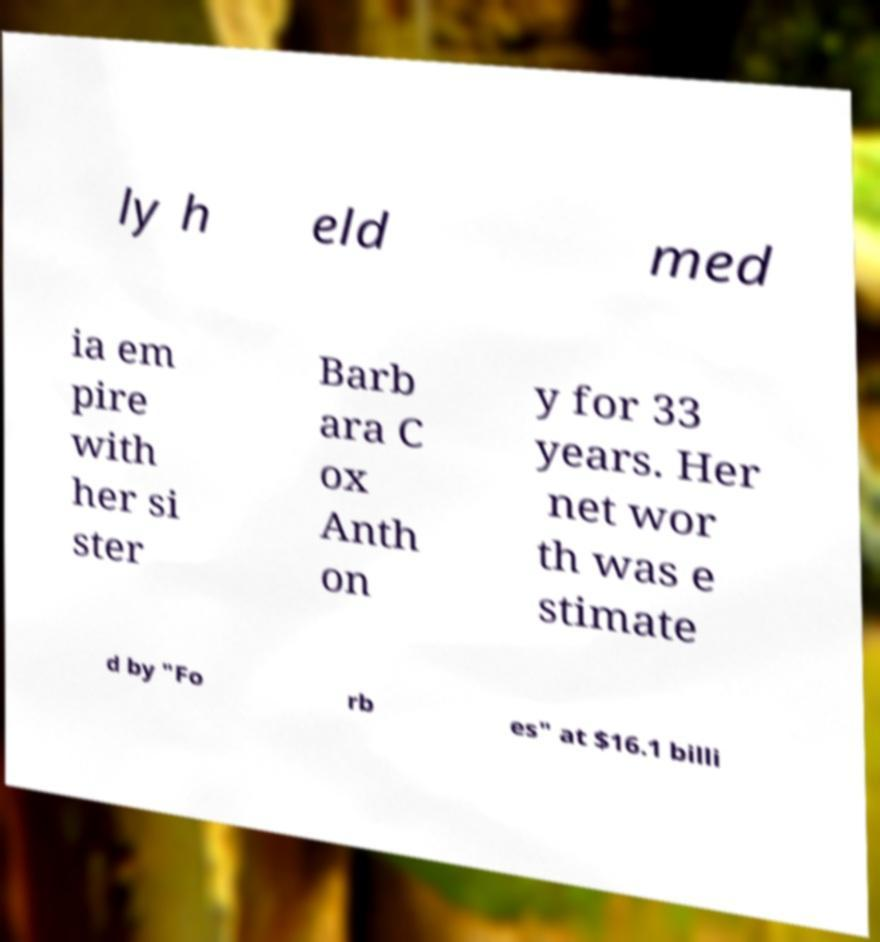There's text embedded in this image that I need extracted. Can you transcribe it verbatim? ly h eld med ia em pire with her si ster Barb ara C ox Anth on y for 33 years. Her net wor th was e stimate d by "Fo rb es" at $16.1 billi 